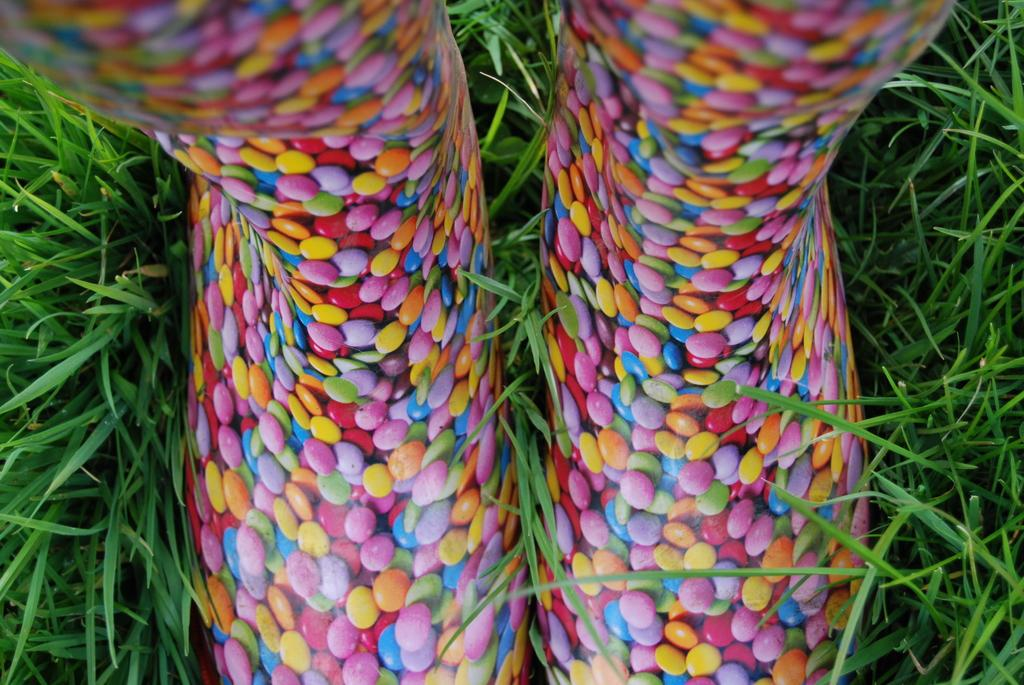What type of objects can be seen in the picture? There are gems in the picture. Can you describe the gems in the picture? The gems are in different colors. What is present on either side of the gems? There is greenery grass on either side of the gems. How many mittens can be seen in the picture? There are no mittens present in the picture; it features gems and greenery grass. What type of knot is used to secure the gems in the picture? There is no knot present in the picture; the gems are simply placed on the greenery grass. 